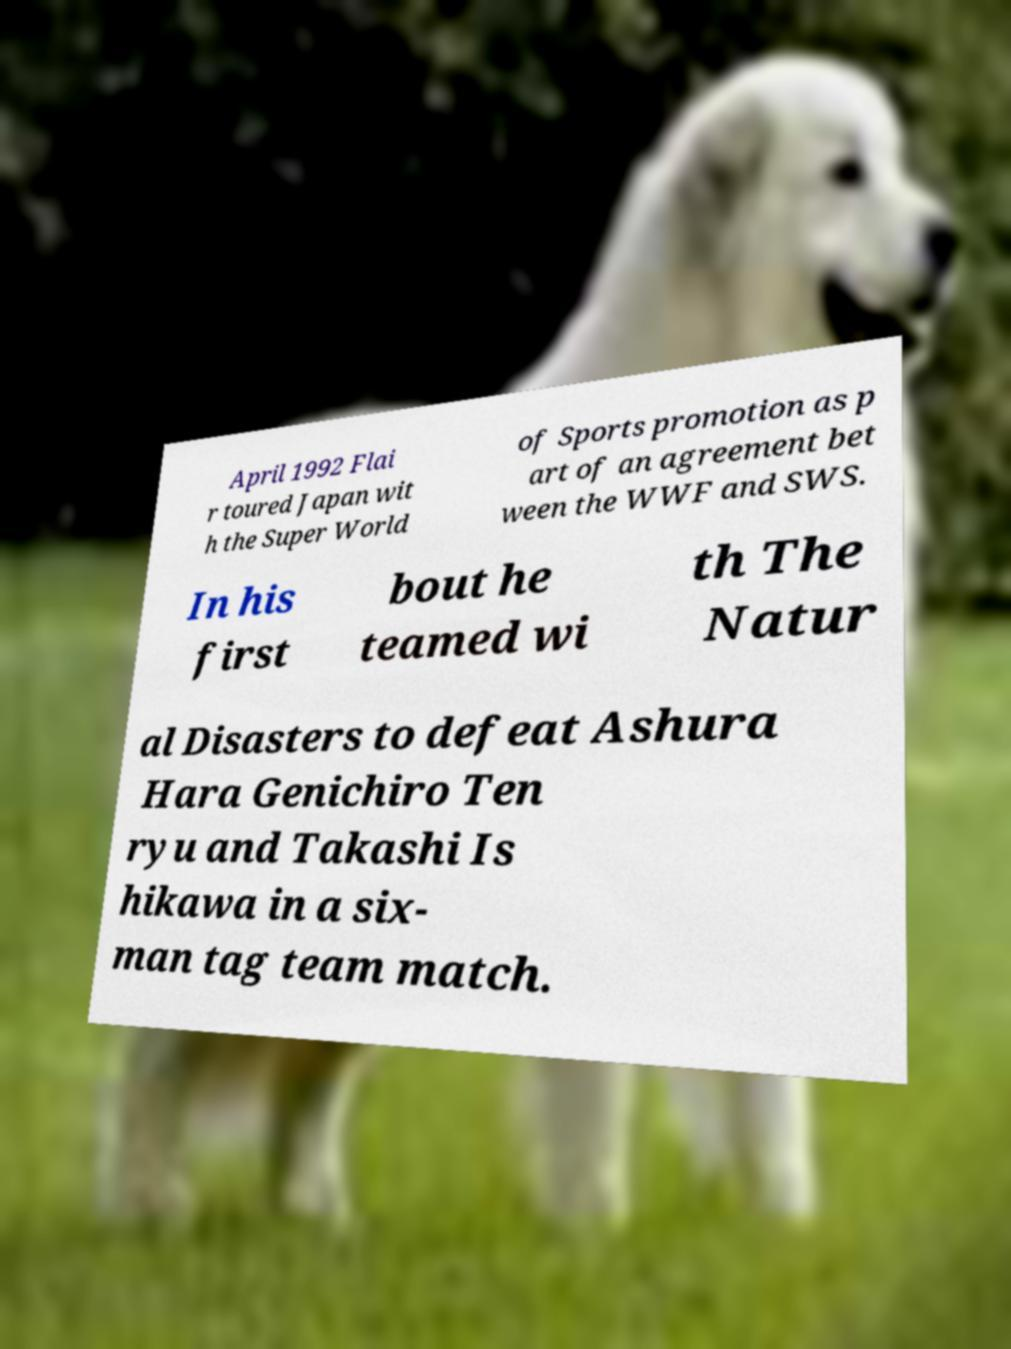Please read and relay the text visible in this image. What does it say? April 1992 Flai r toured Japan wit h the Super World of Sports promotion as p art of an agreement bet ween the WWF and SWS. In his first bout he teamed wi th The Natur al Disasters to defeat Ashura Hara Genichiro Ten ryu and Takashi Is hikawa in a six- man tag team match. 